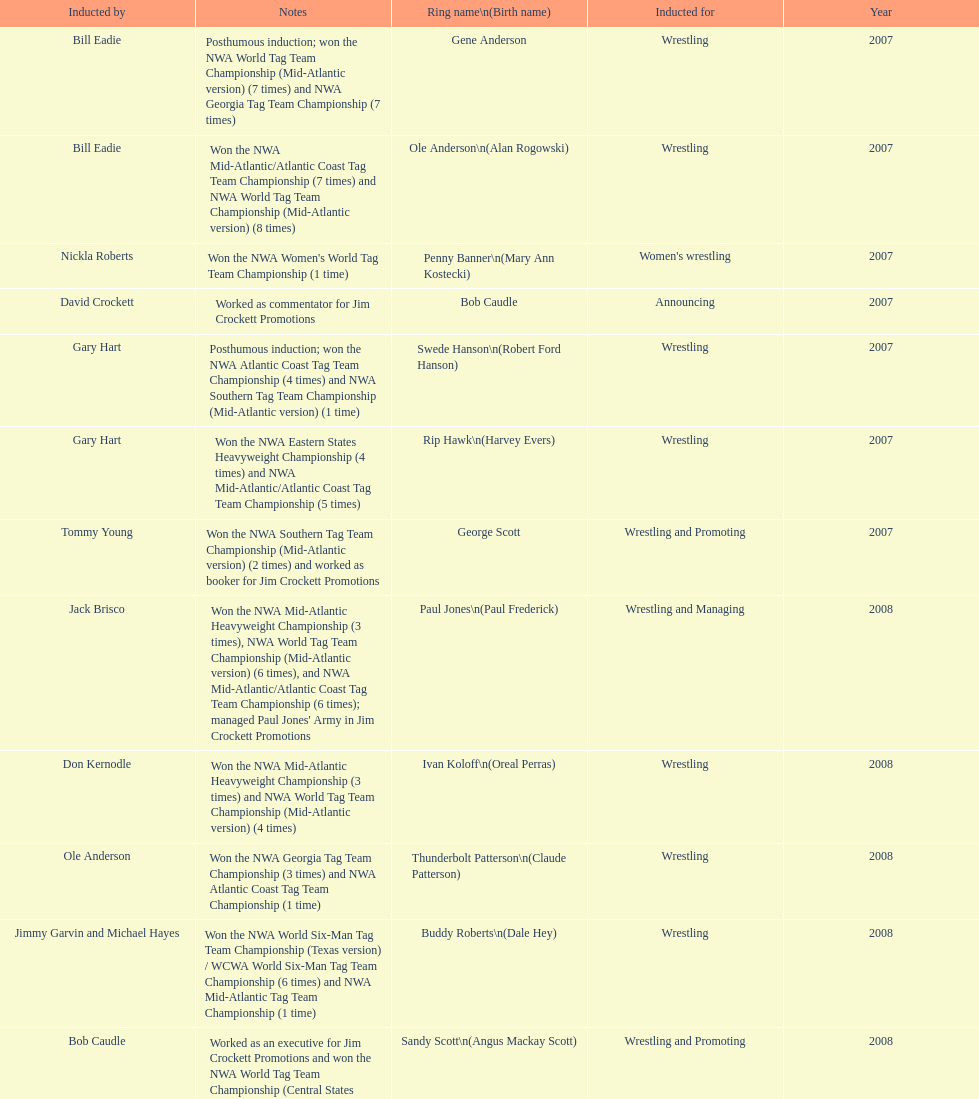Tell me an inductee that was not living at the time. Gene Anderson. 